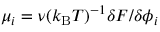Convert formula to latex. <formula><loc_0><loc_0><loc_500><loc_500>\mu _ { i } = \nu ( k _ { B } T ) ^ { - 1 } \delta F / \delta \phi _ { i }</formula> 